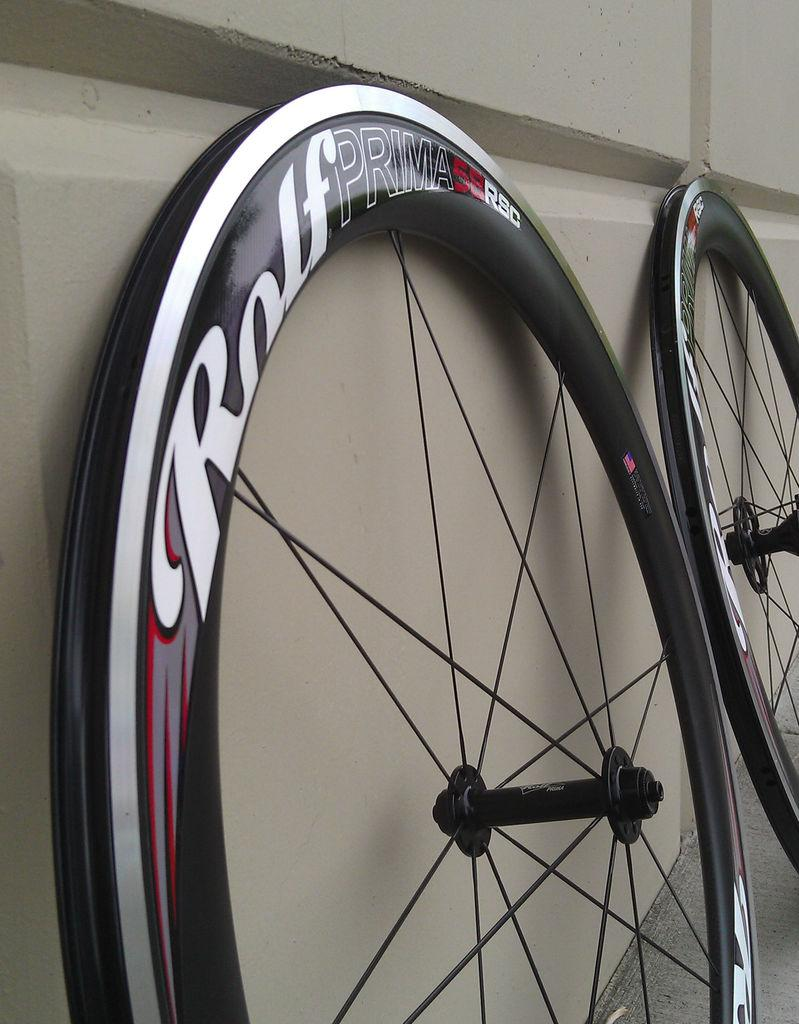What objects in the image have wheels? There are two wheels in the image. What is written or depicted on the wheels? There is text on the wheels. What type of structure can be seen in the image? There is a wall in the image. What surface is visible beneath the wheels? There is a floor visible in the image. How many girls are present in the image? There are no girls present in the image. What expertise is required to understand the text on the wheels? The text on the wheels does not require any specific expertise to understand. 